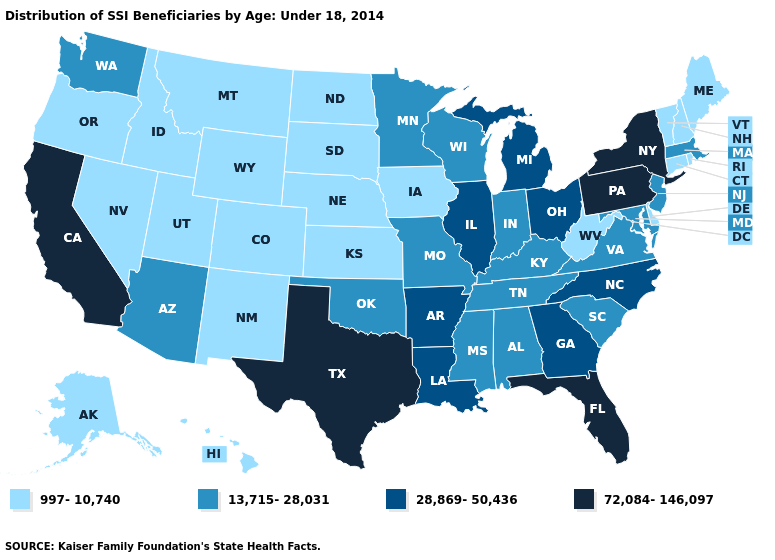Does South Carolina have the highest value in the South?
Be succinct. No. What is the highest value in the MidWest ?
Keep it brief. 28,869-50,436. Does the first symbol in the legend represent the smallest category?
Be succinct. Yes. Name the states that have a value in the range 13,715-28,031?
Concise answer only. Alabama, Arizona, Indiana, Kentucky, Maryland, Massachusetts, Minnesota, Mississippi, Missouri, New Jersey, Oklahoma, South Carolina, Tennessee, Virginia, Washington, Wisconsin. What is the value of Michigan?
Concise answer only. 28,869-50,436. What is the lowest value in the USA?
Concise answer only. 997-10,740. Name the states that have a value in the range 997-10,740?
Short answer required. Alaska, Colorado, Connecticut, Delaware, Hawaii, Idaho, Iowa, Kansas, Maine, Montana, Nebraska, Nevada, New Hampshire, New Mexico, North Dakota, Oregon, Rhode Island, South Dakota, Utah, Vermont, West Virginia, Wyoming. What is the value of Oklahoma?
Be succinct. 13,715-28,031. Among the states that border South Dakota , does Minnesota have the lowest value?
Write a very short answer. No. Among the states that border Wyoming , which have the lowest value?
Keep it brief. Colorado, Idaho, Montana, Nebraska, South Dakota, Utah. What is the lowest value in states that border Iowa?
Keep it brief. 997-10,740. Name the states that have a value in the range 13,715-28,031?
Give a very brief answer. Alabama, Arizona, Indiana, Kentucky, Maryland, Massachusetts, Minnesota, Mississippi, Missouri, New Jersey, Oklahoma, South Carolina, Tennessee, Virginia, Washington, Wisconsin. What is the value of Montana?
Answer briefly. 997-10,740. Among the states that border Georgia , which have the highest value?
Concise answer only. Florida. Name the states that have a value in the range 72,084-146,097?
Short answer required. California, Florida, New York, Pennsylvania, Texas. 